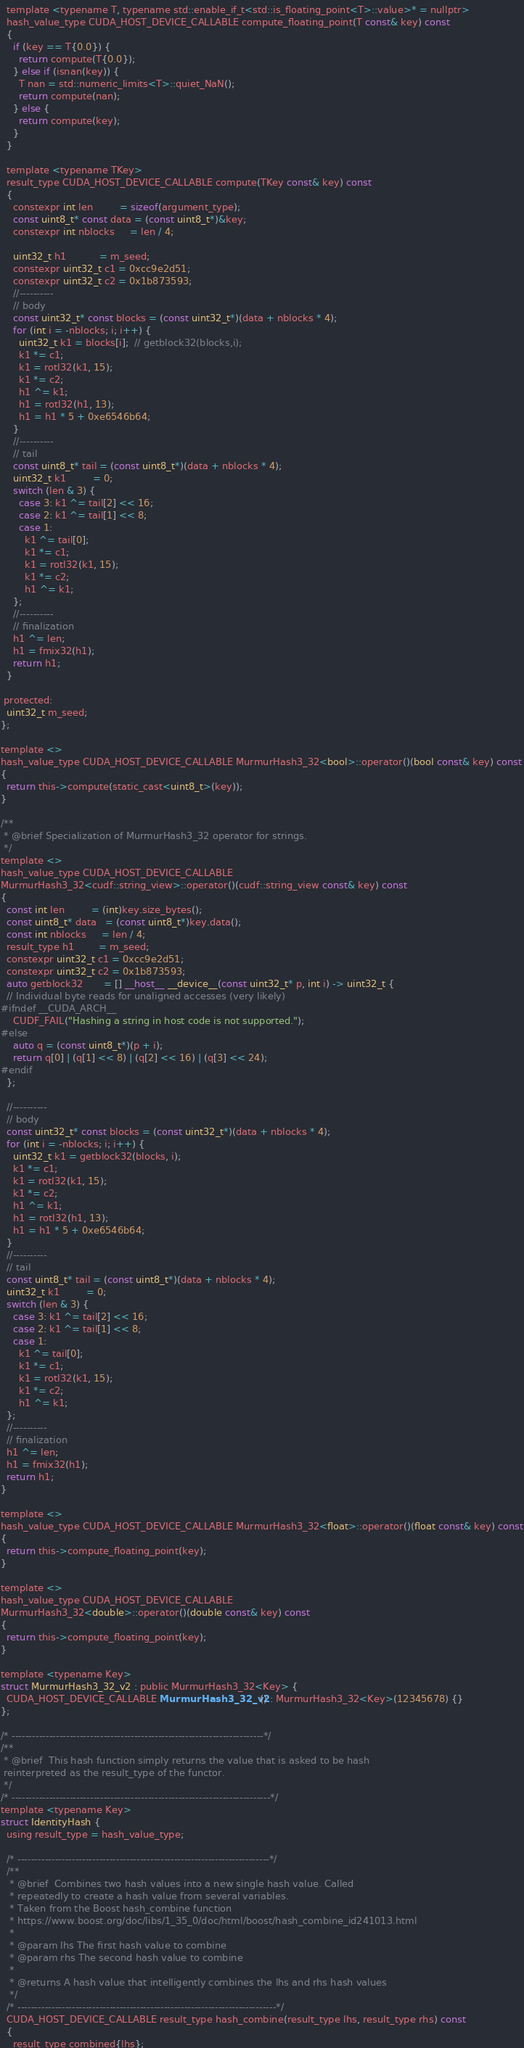<code> <loc_0><loc_0><loc_500><loc_500><_Cuda_>  template <typename T, typename std::enable_if_t<std::is_floating_point<T>::value>* = nullptr>
  hash_value_type CUDA_HOST_DEVICE_CALLABLE compute_floating_point(T const& key) const
  {
    if (key == T{0.0}) {
      return compute(T{0.0});
    } else if (isnan(key)) {
      T nan = std::numeric_limits<T>::quiet_NaN();
      return compute(nan);
    } else {
      return compute(key);
    }
  }

  template <typename TKey>
  result_type CUDA_HOST_DEVICE_CALLABLE compute(TKey const& key) const
  {
    constexpr int len         = sizeof(argument_type);
    const uint8_t* const data = (const uint8_t*)&key;
    constexpr int nblocks     = len / 4;

    uint32_t h1           = m_seed;
    constexpr uint32_t c1 = 0xcc9e2d51;
    constexpr uint32_t c2 = 0x1b873593;
    //----------
    // body
    const uint32_t* const blocks = (const uint32_t*)(data + nblocks * 4);
    for (int i = -nblocks; i; i++) {
      uint32_t k1 = blocks[i];  // getblock32(blocks,i);
      k1 *= c1;
      k1 = rotl32(k1, 15);
      k1 *= c2;
      h1 ^= k1;
      h1 = rotl32(h1, 13);
      h1 = h1 * 5 + 0xe6546b64;
    }
    //----------
    // tail
    const uint8_t* tail = (const uint8_t*)(data + nblocks * 4);
    uint32_t k1         = 0;
    switch (len & 3) {
      case 3: k1 ^= tail[2] << 16;
      case 2: k1 ^= tail[1] << 8;
      case 1:
        k1 ^= tail[0];
        k1 *= c1;
        k1 = rotl32(k1, 15);
        k1 *= c2;
        h1 ^= k1;
    };
    //----------
    // finalization
    h1 ^= len;
    h1 = fmix32(h1);
    return h1;
  }

 protected:
  uint32_t m_seed;
};

template <>
hash_value_type CUDA_HOST_DEVICE_CALLABLE MurmurHash3_32<bool>::operator()(bool const& key) const
{
  return this->compute(static_cast<uint8_t>(key));
}

/**
 * @brief Specialization of MurmurHash3_32 operator for strings.
 */
template <>
hash_value_type CUDA_HOST_DEVICE_CALLABLE
MurmurHash3_32<cudf::string_view>::operator()(cudf::string_view const& key) const
{
  const int len         = (int)key.size_bytes();
  const uint8_t* data   = (const uint8_t*)key.data();
  const int nblocks     = len / 4;
  result_type h1        = m_seed;
  constexpr uint32_t c1 = 0xcc9e2d51;
  constexpr uint32_t c2 = 0x1b873593;
  auto getblock32       = [] __host__ __device__(const uint32_t* p, int i) -> uint32_t {
  // Individual byte reads for unaligned accesses (very likely)
#ifndef __CUDA_ARCH__
    CUDF_FAIL("Hashing a string in host code is not supported.");
#else
    auto q = (const uint8_t*)(p + i);
    return q[0] | (q[1] << 8) | (q[2] << 16) | (q[3] << 24);
#endif
  };

  //----------
  // body
  const uint32_t* const blocks = (const uint32_t*)(data + nblocks * 4);
  for (int i = -nblocks; i; i++) {
    uint32_t k1 = getblock32(blocks, i);
    k1 *= c1;
    k1 = rotl32(k1, 15);
    k1 *= c2;
    h1 ^= k1;
    h1 = rotl32(h1, 13);
    h1 = h1 * 5 + 0xe6546b64;
  }
  //----------
  // tail
  const uint8_t* tail = (const uint8_t*)(data + nblocks * 4);
  uint32_t k1         = 0;
  switch (len & 3) {
    case 3: k1 ^= tail[2] << 16;
    case 2: k1 ^= tail[1] << 8;
    case 1:
      k1 ^= tail[0];
      k1 *= c1;
      k1 = rotl32(k1, 15);
      k1 *= c2;
      h1 ^= k1;
  };
  //----------
  // finalization
  h1 ^= len;
  h1 = fmix32(h1);
  return h1;
}

template <>
hash_value_type CUDA_HOST_DEVICE_CALLABLE MurmurHash3_32<float>::operator()(float const& key) const
{
  return this->compute_floating_point(key);
}

template <>
hash_value_type CUDA_HOST_DEVICE_CALLABLE
MurmurHash3_32<double>::operator()(double const& key) const
{
  return this->compute_floating_point(key);
}

template <typename Key>
struct MurmurHash3_32_v2 : public MurmurHash3_32<Key> {
  CUDA_HOST_DEVICE_CALLABLE MurmurHash3_32_v2() : MurmurHash3_32<Key>(12345678) {}
};

/* --------------------------------------------------------------------------*/
/**
 * @brief  This hash function simply returns the value that is asked to be hash
 reinterpreted as the result_type of the functor.
 */
/* ----------------------------------------------------------------------------*/
template <typename Key>
struct IdentityHash {
  using result_type = hash_value_type;

  /* --------------------------------------------------------------------------*/
  /**
   * @brief  Combines two hash values into a new single hash value. Called
   * repeatedly to create a hash value from several variables.
   * Taken from the Boost hash_combine function
   * https://www.boost.org/doc/libs/1_35_0/doc/html/boost/hash_combine_id241013.html
   *
   * @param lhs The first hash value to combine
   * @param rhs The second hash value to combine
   *
   * @returns A hash value that intelligently combines the lhs and rhs hash values
   */
  /* ----------------------------------------------------------------------------*/
  CUDA_HOST_DEVICE_CALLABLE result_type hash_combine(result_type lhs, result_type rhs) const
  {
    result_type combined{lhs};
</code> 